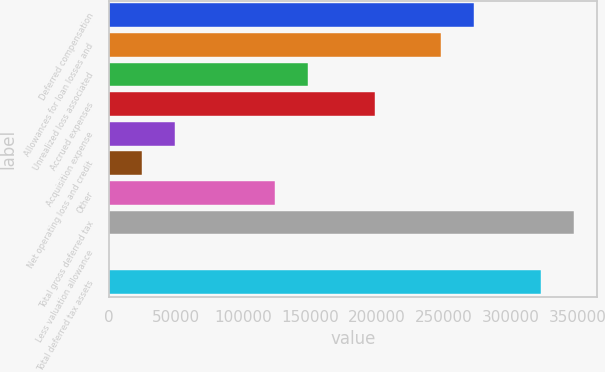<chart> <loc_0><loc_0><loc_500><loc_500><bar_chart><fcel>Deferred compensation<fcel>Allowances for loan losses and<fcel>Unrealized loss associated<fcel>Accrued expenses<fcel>Acquisition expense<fcel>Net operating loss and credit<fcel>Other<fcel>Total gross deferred tax<fcel>Less valuation allowance<fcel>Total deferred tax assets<nl><fcel>273119<fcel>248291<fcel>148978<fcel>198635<fcel>49665.4<fcel>24837.2<fcel>124150<fcel>347604<fcel>9<fcel>322776<nl></chart> 